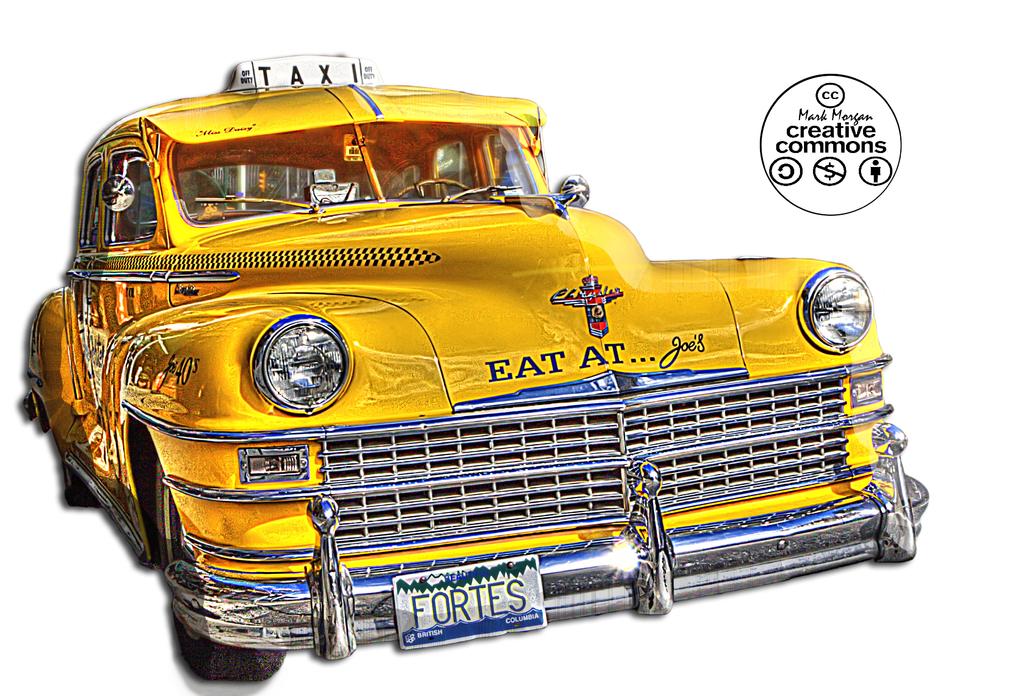What does the license plate say?
Provide a short and direct response. Fortes. Where should people eat at?
Give a very brief answer. Joe's. 